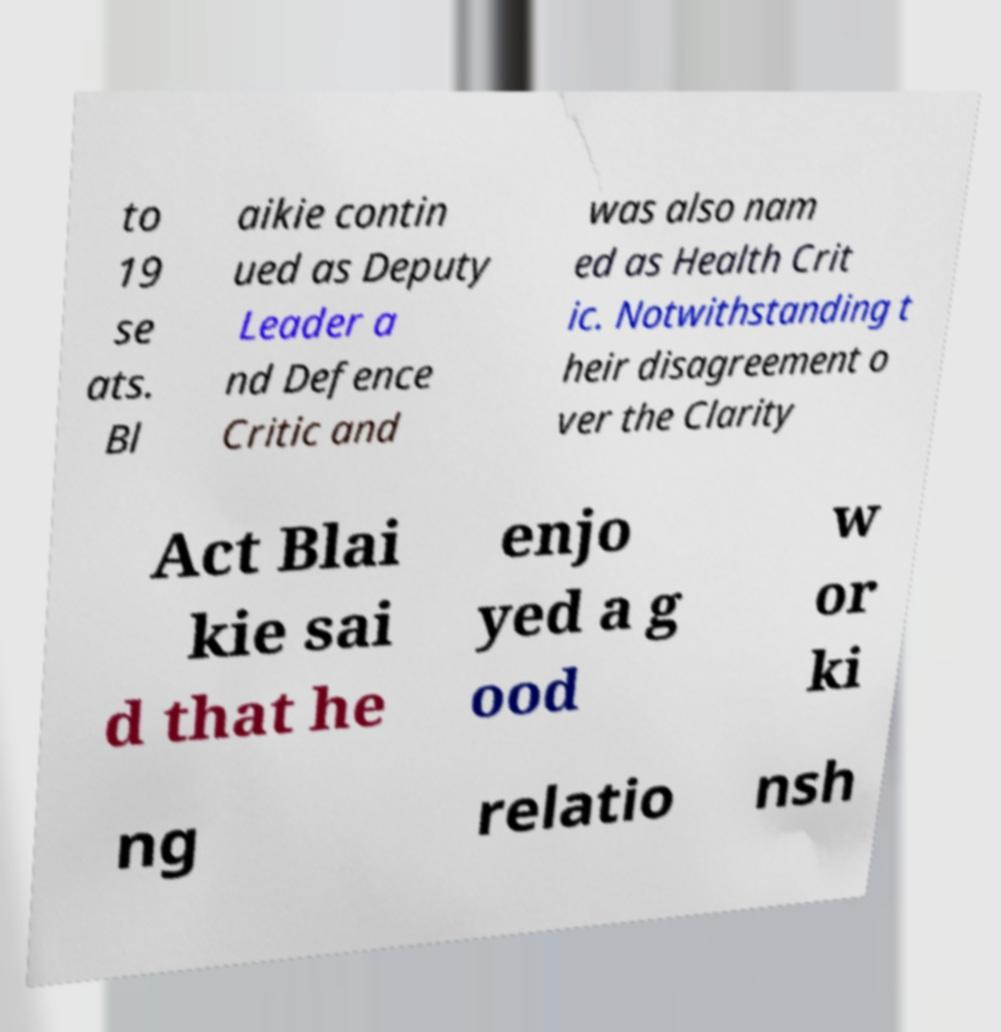Please identify and transcribe the text found in this image. to 19 se ats. Bl aikie contin ued as Deputy Leader a nd Defence Critic and was also nam ed as Health Crit ic. Notwithstanding t heir disagreement o ver the Clarity Act Blai kie sai d that he enjo yed a g ood w or ki ng relatio nsh 